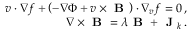<formula> <loc_0><loc_0><loc_500><loc_500>\begin{array} { r } { v \cdot \nabla f + \left ( - \nabla \Phi + v \times B \right ) \cdot \nabla _ { v } f = 0 \, , } \\ { \nabla \times B = \lambda B + J _ { k } \, . } \end{array}</formula> 